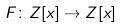Convert formula to latex. <formula><loc_0><loc_0><loc_500><loc_500>F \colon Z [ x ] \rightarrow Z [ x ]</formula> 